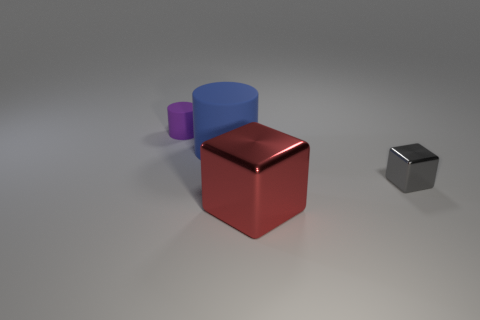Add 1 red cubes. How many objects exist? 5 Subtract 0 cyan cylinders. How many objects are left? 4 Subtract 1 blocks. How many blocks are left? 1 Subtract all brown blocks. Subtract all purple balls. How many blocks are left? 2 Subtract all blue spheres. How many gray cylinders are left? 0 Subtract all metal objects. Subtract all small purple objects. How many objects are left? 1 Add 3 tiny gray cubes. How many tiny gray cubes are left? 4 Add 4 cyan spheres. How many cyan spheres exist? 4 